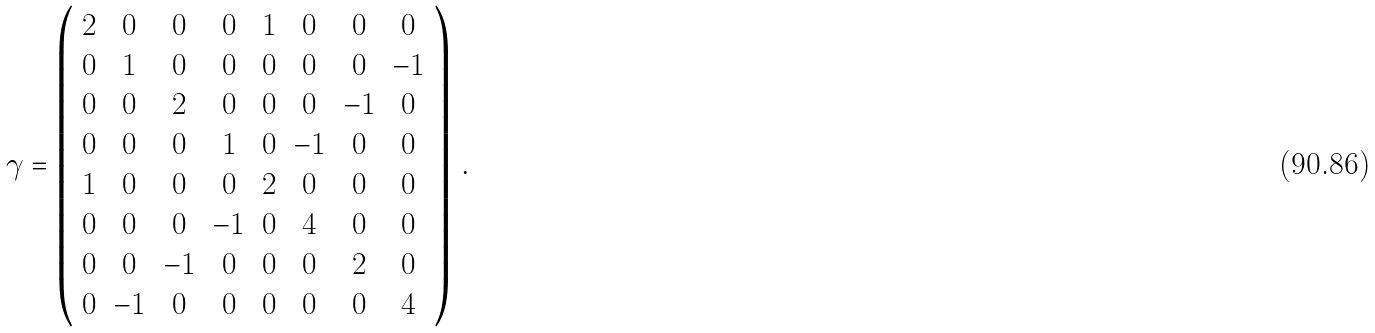Convert formula to latex. <formula><loc_0><loc_0><loc_500><loc_500>\gamma = \left ( \begin{array} { c c c c c c c c } 2 & 0 & 0 & 0 & 1 & 0 & 0 & 0 \\ 0 & 1 & 0 & 0 & 0 & 0 & 0 & - 1 \\ 0 & 0 & 2 & 0 & 0 & 0 & - 1 & 0 \\ 0 & 0 & 0 & 1 & 0 & - 1 & 0 & 0 \\ 1 & 0 & 0 & 0 & 2 & 0 & 0 & 0 \\ 0 & 0 & 0 & - 1 & 0 & 4 & 0 & 0 \\ 0 & 0 & - 1 & 0 & 0 & 0 & 2 & 0 \\ 0 & - 1 & 0 & 0 & 0 & 0 & 0 & 4 \end{array} \right ) \, .</formula> 